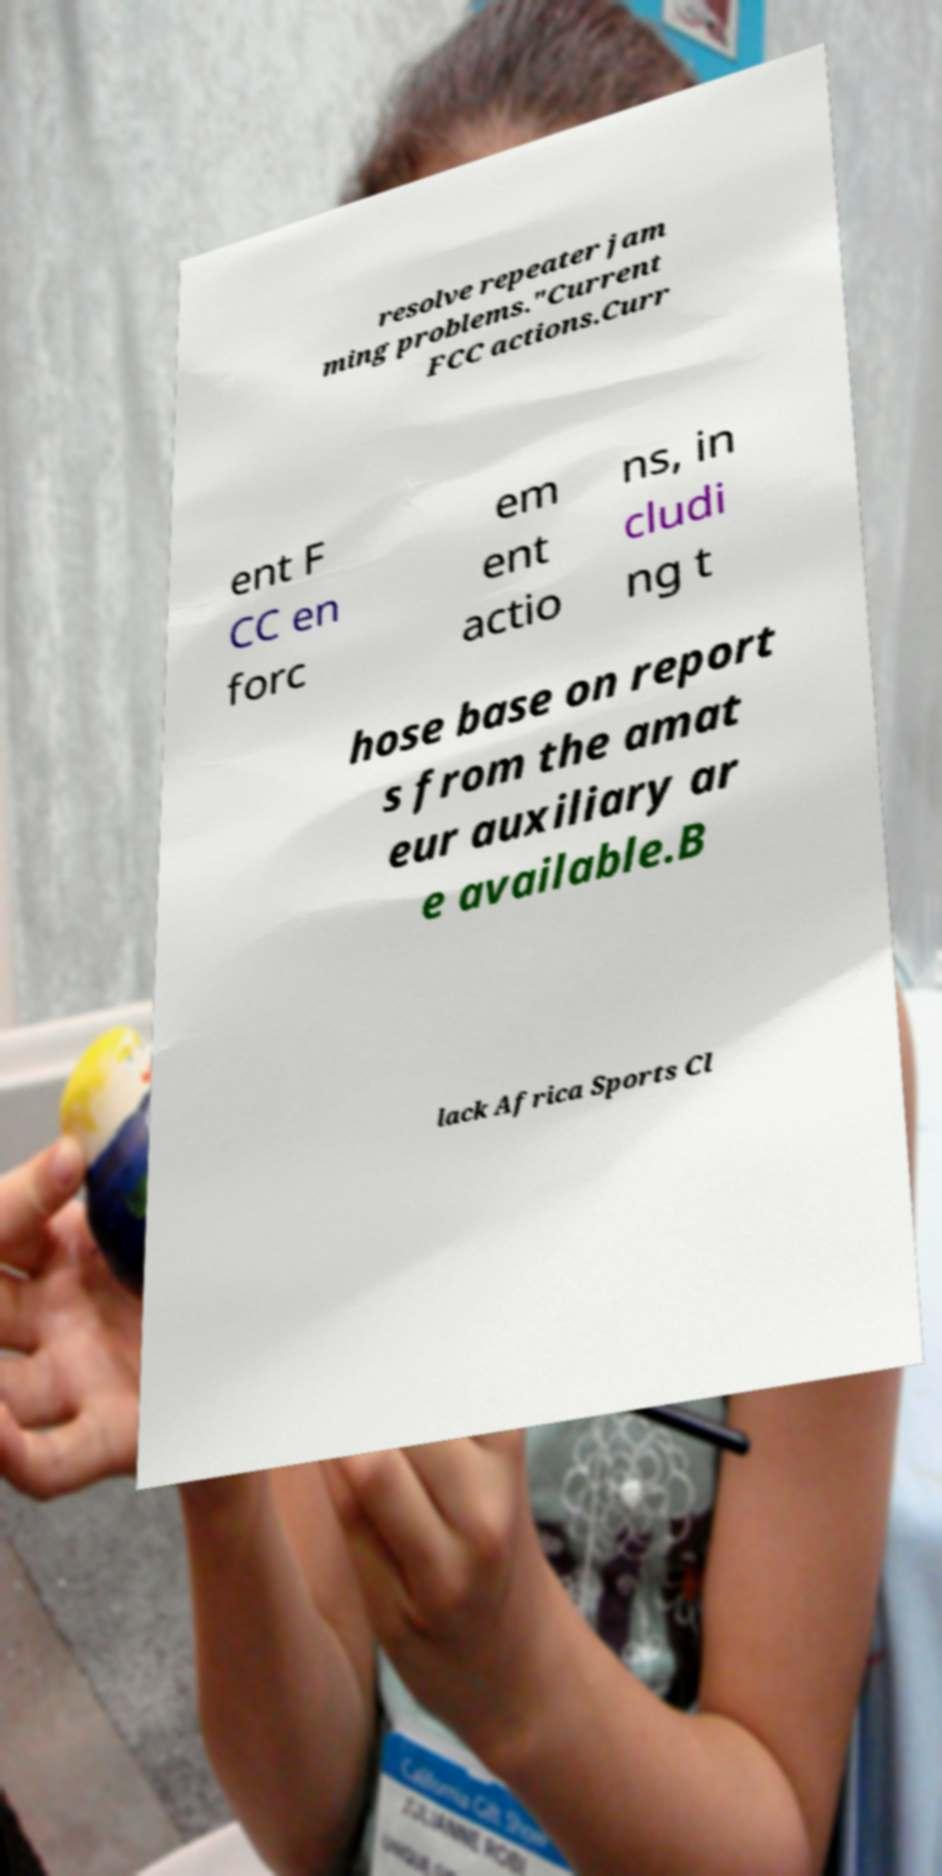For documentation purposes, I need the text within this image transcribed. Could you provide that? resolve repeater jam ming problems."Current FCC actions.Curr ent F CC en forc em ent actio ns, in cludi ng t hose base on report s from the amat eur auxiliary ar e available.B lack Africa Sports Cl 